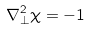Convert formula to latex. <formula><loc_0><loc_0><loc_500><loc_500>\nabla _ { \perp } ^ { 2 } \chi = - 1</formula> 